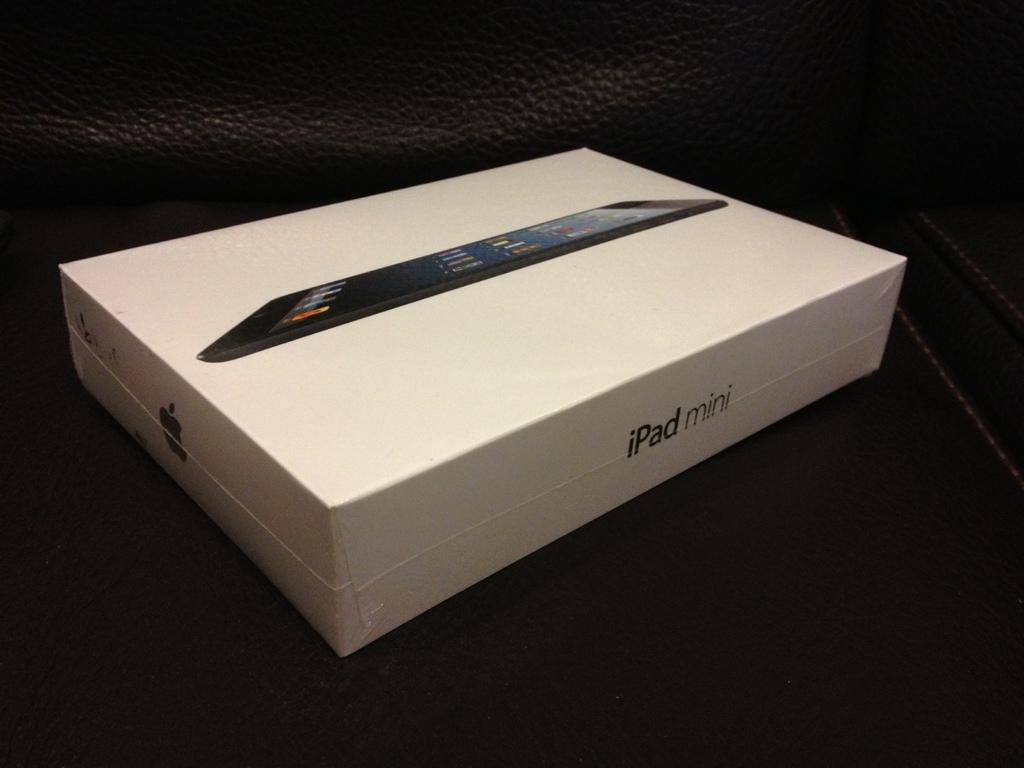Provide a one-sentence caption for the provided image. A white iPad mini box has an image of the device on the box. 